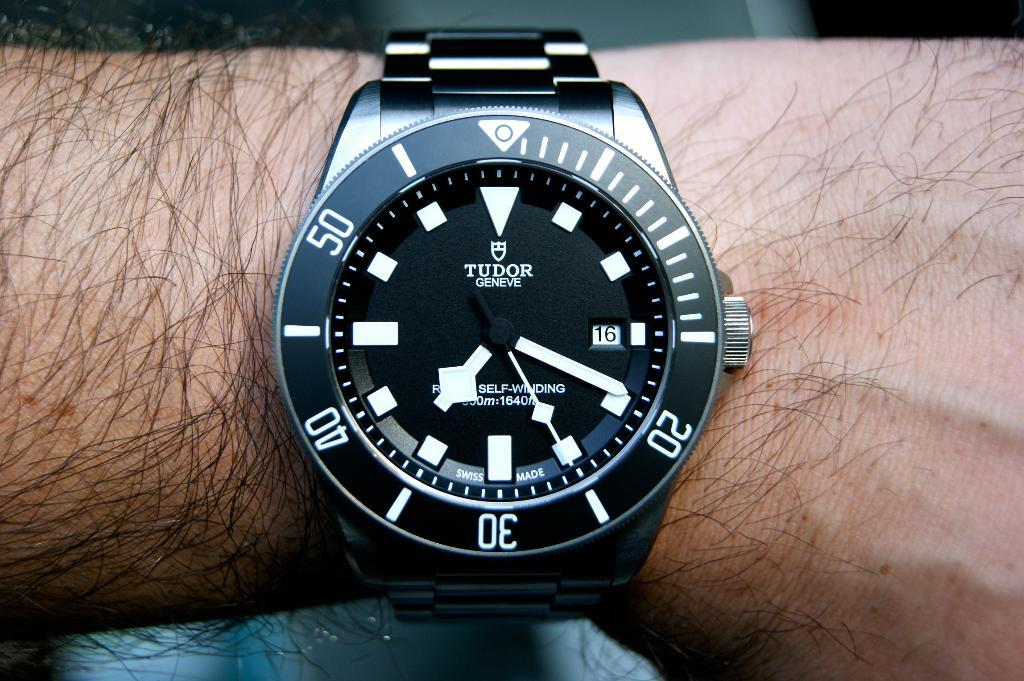Provide a one-sentence caption for the provided image. a tudor watch is on a persons arm. 